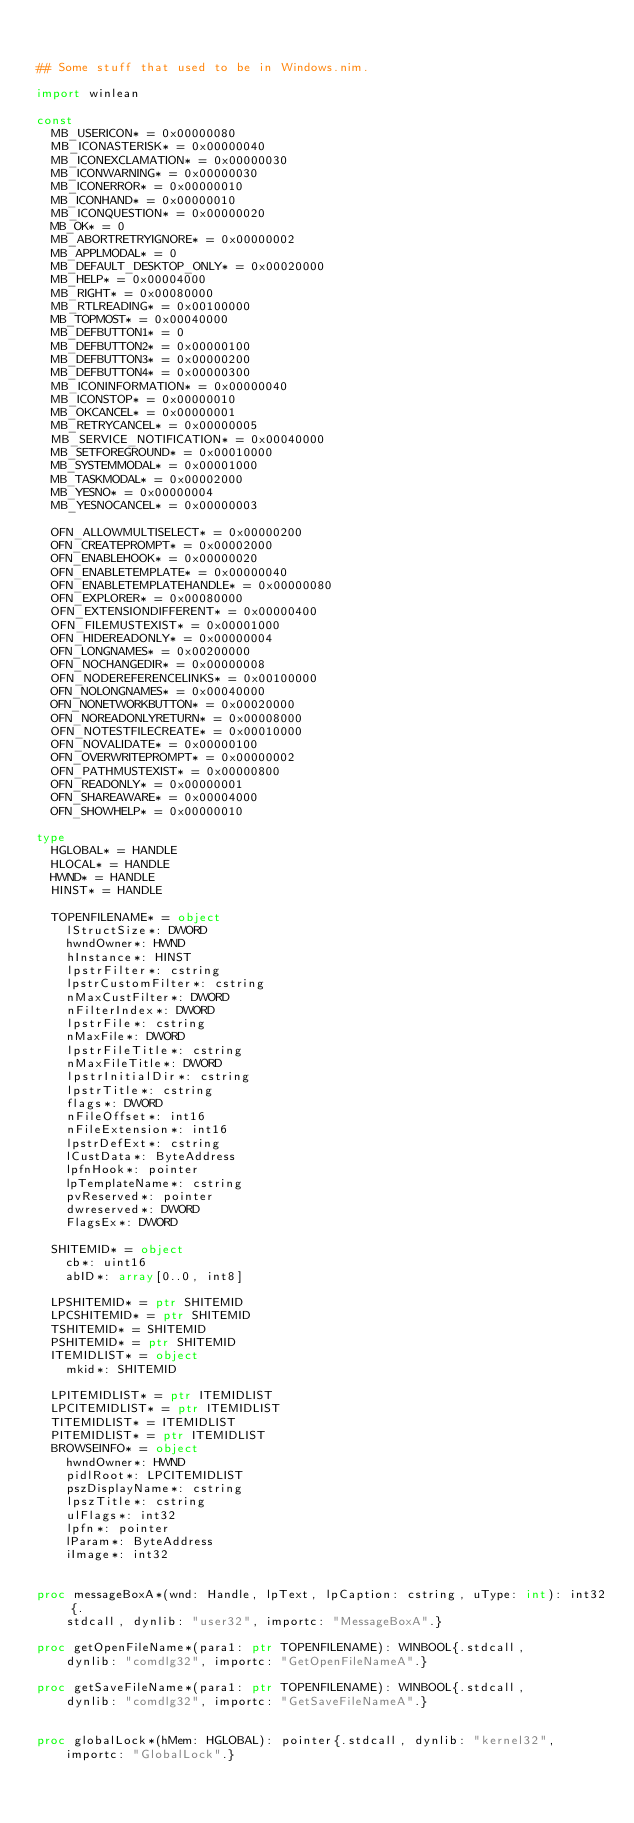<code> <loc_0><loc_0><loc_500><loc_500><_Nim_>

## Some stuff that used to be in Windows.nim.

import winlean

const
  MB_USERICON* = 0x00000080
  MB_ICONASTERISK* = 0x00000040
  MB_ICONEXCLAMATION* = 0x00000030
  MB_ICONWARNING* = 0x00000030
  MB_ICONERROR* = 0x00000010
  MB_ICONHAND* = 0x00000010
  MB_ICONQUESTION* = 0x00000020
  MB_OK* = 0
  MB_ABORTRETRYIGNORE* = 0x00000002
  MB_APPLMODAL* = 0
  MB_DEFAULT_DESKTOP_ONLY* = 0x00020000
  MB_HELP* = 0x00004000
  MB_RIGHT* = 0x00080000
  MB_RTLREADING* = 0x00100000
  MB_TOPMOST* = 0x00040000
  MB_DEFBUTTON1* = 0
  MB_DEFBUTTON2* = 0x00000100
  MB_DEFBUTTON3* = 0x00000200
  MB_DEFBUTTON4* = 0x00000300
  MB_ICONINFORMATION* = 0x00000040
  MB_ICONSTOP* = 0x00000010
  MB_OKCANCEL* = 0x00000001
  MB_RETRYCANCEL* = 0x00000005
  MB_SERVICE_NOTIFICATION* = 0x00040000
  MB_SETFOREGROUND* = 0x00010000
  MB_SYSTEMMODAL* = 0x00001000
  MB_TASKMODAL* = 0x00002000
  MB_YESNO* = 0x00000004
  MB_YESNOCANCEL* = 0x00000003

  OFN_ALLOWMULTISELECT* = 0x00000200
  OFN_CREATEPROMPT* = 0x00002000
  OFN_ENABLEHOOK* = 0x00000020
  OFN_ENABLETEMPLATE* = 0x00000040
  OFN_ENABLETEMPLATEHANDLE* = 0x00000080
  OFN_EXPLORER* = 0x00080000
  OFN_EXTENSIONDIFFERENT* = 0x00000400
  OFN_FILEMUSTEXIST* = 0x00001000
  OFN_HIDEREADONLY* = 0x00000004
  OFN_LONGNAMES* = 0x00200000
  OFN_NOCHANGEDIR* = 0x00000008
  OFN_NODEREFERENCELINKS* = 0x00100000
  OFN_NOLONGNAMES* = 0x00040000
  OFN_NONETWORKBUTTON* = 0x00020000
  OFN_NOREADONLYRETURN* = 0x00008000
  OFN_NOTESTFILECREATE* = 0x00010000
  OFN_NOVALIDATE* = 0x00000100
  OFN_OVERWRITEPROMPT* = 0x00000002
  OFN_PATHMUSTEXIST* = 0x00000800
  OFN_READONLY* = 0x00000001
  OFN_SHAREAWARE* = 0x00004000
  OFN_SHOWHELP* = 0x00000010

type
  HGLOBAL* = HANDLE
  HLOCAL* = HANDLE
  HWND* = HANDLE
  HINST* = HANDLE

  TOPENFILENAME* = object
    lStructSize*: DWORD
    hwndOwner*: HWND
    hInstance*: HINST
    lpstrFilter*: cstring
    lpstrCustomFilter*: cstring
    nMaxCustFilter*: DWORD
    nFilterIndex*: DWORD
    lpstrFile*: cstring
    nMaxFile*: DWORD
    lpstrFileTitle*: cstring
    nMaxFileTitle*: DWORD
    lpstrInitialDir*: cstring
    lpstrTitle*: cstring
    flags*: DWORD
    nFileOffset*: int16
    nFileExtension*: int16
    lpstrDefExt*: cstring
    lCustData*: ByteAddress
    lpfnHook*: pointer
    lpTemplateName*: cstring
    pvReserved*: pointer
    dwreserved*: DWORD
    FlagsEx*: DWORD

  SHITEMID* = object
    cb*: uint16
    abID*: array[0..0, int8]

  LPSHITEMID* = ptr SHITEMID
  LPCSHITEMID* = ptr SHITEMID
  TSHITEMID* = SHITEMID
  PSHITEMID* = ptr SHITEMID
  ITEMIDLIST* = object
    mkid*: SHITEMID

  LPITEMIDLIST* = ptr ITEMIDLIST
  LPCITEMIDLIST* = ptr ITEMIDLIST
  TITEMIDLIST* = ITEMIDLIST
  PITEMIDLIST* = ptr ITEMIDLIST
  BROWSEINFO* = object
    hwndOwner*: HWND
    pidlRoot*: LPCITEMIDLIST
    pszDisplayName*: cstring
    lpszTitle*: cstring
    ulFlags*: int32
    lpfn*: pointer
    lParam*: ByteAddress
    iImage*: int32


proc messageBoxA*(wnd: Handle, lpText, lpCaption: cstring, uType: int): int32{.
    stdcall, dynlib: "user32", importc: "MessageBoxA".}

proc getOpenFileName*(para1: ptr TOPENFILENAME): WINBOOL{.stdcall,
    dynlib: "comdlg32", importc: "GetOpenFileNameA".}

proc getSaveFileName*(para1: ptr TOPENFILENAME): WINBOOL{.stdcall,
    dynlib: "comdlg32", importc: "GetSaveFileNameA".}


proc globalLock*(hMem: HGLOBAL): pointer{.stdcall, dynlib: "kernel32",
    importc: "GlobalLock".}</code> 